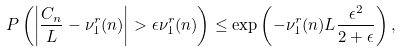Convert formula to latex. <formula><loc_0><loc_0><loc_500><loc_500>P \left ( \left | \frac { C _ { n } } { L } - \nu _ { 1 } ^ { r } ( n ) \right | > \epsilon \nu _ { 1 } ^ { r } ( n ) \right ) \leq \exp \left ( - \nu _ { 1 } ^ { r } ( n ) L \frac { \epsilon ^ { 2 } } { 2 + \epsilon } \right ) ,</formula> 